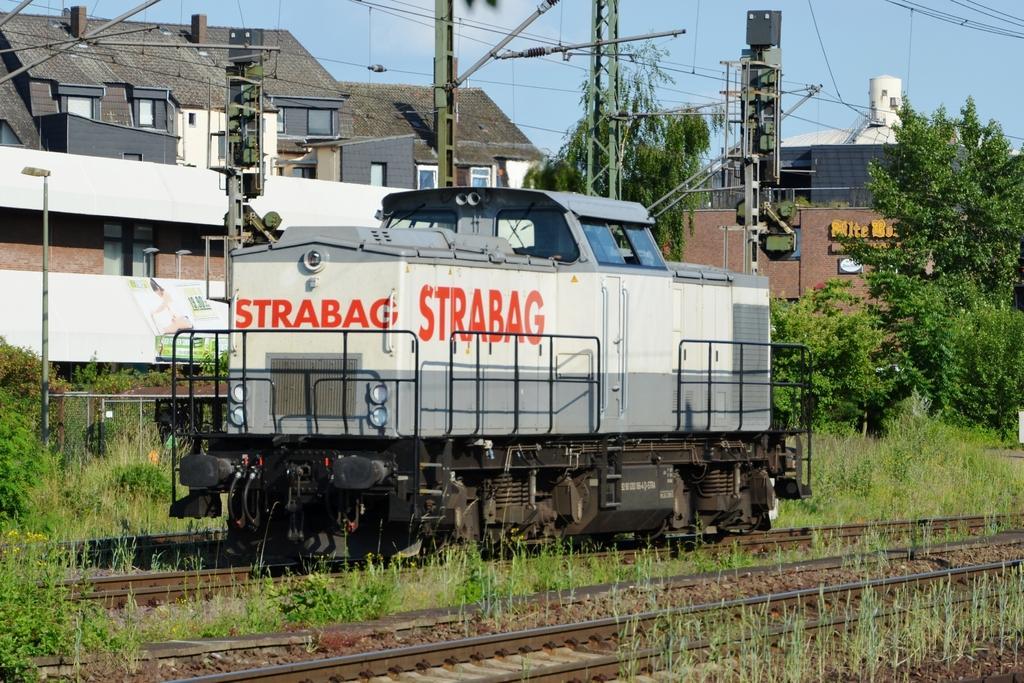In one or two sentences, can you explain what this image depicts? In this picture we can see railway tracks, grass and some stones at the bottom, there is a train engine in the middle, in the background there are some buildings, poles , wires. On the left side there are some plants, we can see trees on the right side, there is the sky at the top of the picture. 